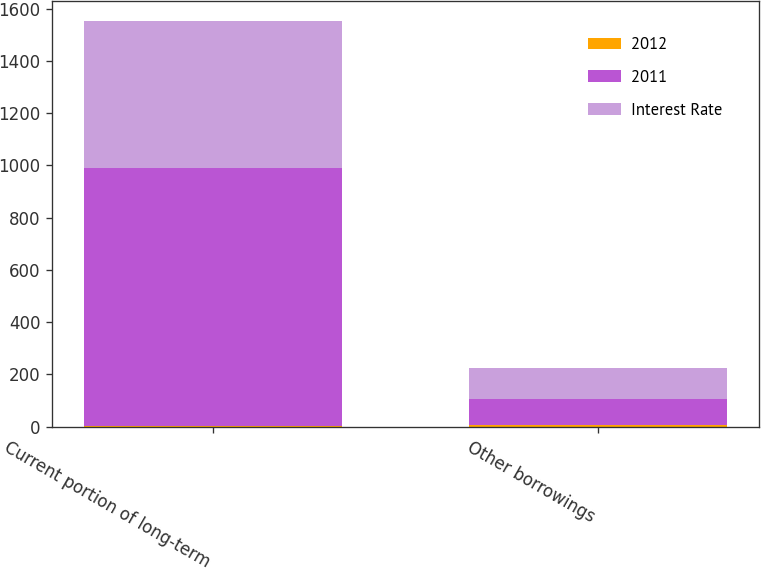Convert chart to OTSL. <chart><loc_0><loc_0><loc_500><loc_500><stacked_bar_chart><ecel><fcel>Current portion of long-term<fcel>Other borrowings<nl><fcel>2012<fcel>3.83<fcel>4.7<nl><fcel>2011<fcel>986<fcel>99<nl><fcel>Interest Rate<fcel>563<fcel>119<nl></chart> 